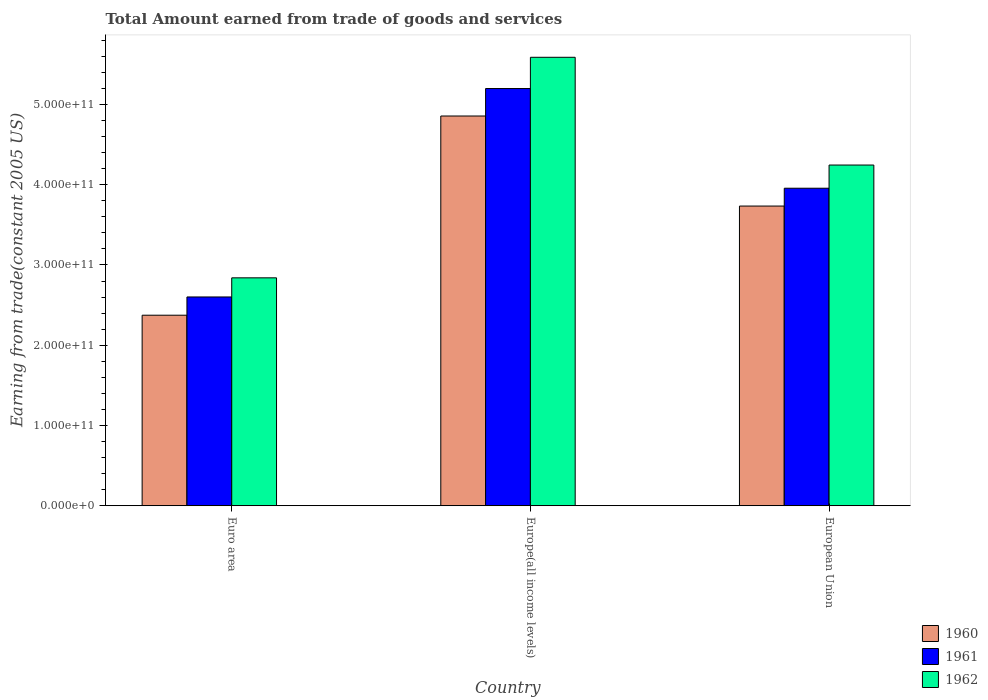How many different coloured bars are there?
Your answer should be compact. 3. How many bars are there on the 1st tick from the left?
Make the answer very short. 3. What is the label of the 1st group of bars from the left?
Keep it short and to the point. Euro area. In how many cases, is the number of bars for a given country not equal to the number of legend labels?
Give a very brief answer. 0. What is the total amount earned by trading goods and services in 1960 in Euro area?
Give a very brief answer. 2.37e+11. Across all countries, what is the maximum total amount earned by trading goods and services in 1961?
Ensure brevity in your answer.  5.20e+11. Across all countries, what is the minimum total amount earned by trading goods and services in 1962?
Offer a very short reply. 2.84e+11. In which country was the total amount earned by trading goods and services in 1960 maximum?
Make the answer very short. Europe(all income levels). What is the total total amount earned by trading goods and services in 1960 in the graph?
Keep it short and to the point. 1.10e+12. What is the difference between the total amount earned by trading goods and services in 1960 in Europe(all income levels) and that in European Union?
Make the answer very short. 1.12e+11. What is the difference between the total amount earned by trading goods and services in 1962 in Euro area and the total amount earned by trading goods and services in 1960 in Europe(all income levels)?
Your response must be concise. -2.02e+11. What is the average total amount earned by trading goods and services in 1961 per country?
Make the answer very short. 3.92e+11. What is the difference between the total amount earned by trading goods and services of/in 1960 and total amount earned by trading goods and services of/in 1962 in Europe(all income levels)?
Provide a succinct answer. -7.32e+1. In how many countries, is the total amount earned by trading goods and services in 1960 greater than 340000000000 US$?
Provide a short and direct response. 2. What is the ratio of the total amount earned by trading goods and services in 1961 in Euro area to that in Europe(all income levels)?
Provide a succinct answer. 0.5. What is the difference between the highest and the second highest total amount earned by trading goods and services in 1960?
Provide a short and direct response. 1.12e+11. What is the difference between the highest and the lowest total amount earned by trading goods and services in 1960?
Provide a short and direct response. 2.48e+11. How many bars are there?
Your answer should be very brief. 9. What is the difference between two consecutive major ticks on the Y-axis?
Provide a succinct answer. 1.00e+11. Are the values on the major ticks of Y-axis written in scientific E-notation?
Your answer should be compact. Yes. Does the graph contain any zero values?
Ensure brevity in your answer.  No. Where does the legend appear in the graph?
Your answer should be compact. Bottom right. How many legend labels are there?
Give a very brief answer. 3. What is the title of the graph?
Make the answer very short. Total Amount earned from trade of goods and services. What is the label or title of the Y-axis?
Offer a terse response. Earning from trade(constant 2005 US). What is the Earning from trade(constant 2005 US) in 1960 in Euro area?
Offer a terse response. 2.37e+11. What is the Earning from trade(constant 2005 US) of 1961 in Euro area?
Give a very brief answer. 2.60e+11. What is the Earning from trade(constant 2005 US) in 1962 in Euro area?
Your answer should be compact. 2.84e+11. What is the Earning from trade(constant 2005 US) in 1960 in Europe(all income levels)?
Offer a terse response. 4.86e+11. What is the Earning from trade(constant 2005 US) in 1961 in Europe(all income levels)?
Ensure brevity in your answer.  5.20e+11. What is the Earning from trade(constant 2005 US) of 1962 in Europe(all income levels)?
Offer a terse response. 5.59e+11. What is the Earning from trade(constant 2005 US) in 1960 in European Union?
Give a very brief answer. 3.73e+11. What is the Earning from trade(constant 2005 US) of 1961 in European Union?
Give a very brief answer. 3.96e+11. What is the Earning from trade(constant 2005 US) of 1962 in European Union?
Your answer should be very brief. 4.24e+11. Across all countries, what is the maximum Earning from trade(constant 2005 US) in 1960?
Provide a short and direct response. 4.86e+11. Across all countries, what is the maximum Earning from trade(constant 2005 US) of 1961?
Your answer should be compact. 5.20e+11. Across all countries, what is the maximum Earning from trade(constant 2005 US) in 1962?
Offer a very short reply. 5.59e+11. Across all countries, what is the minimum Earning from trade(constant 2005 US) in 1960?
Provide a succinct answer. 2.37e+11. Across all countries, what is the minimum Earning from trade(constant 2005 US) of 1961?
Your answer should be compact. 2.60e+11. Across all countries, what is the minimum Earning from trade(constant 2005 US) in 1962?
Make the answer very short. 2.84e+11. What is the total Earning from trade(constant 2005 US) in 1960 in the graph?
Provide a succinct answer. 1.10e+12. What is the total Earning from trade(constant 2005 US) in 1961 in the graph?
Offer a very short reply. 1.18e+12. What is the total Earning from trade(constant 2005 US) of 1962 in the graph?
Your answer should be compact. 1.27e+12. What is the difference between the Earning from trade(constant 2005 US) of 1960 in Euro area and that in Europe(all income levels)?
Your answer should be very brief. -2.48e+11. What is the difference between the Earning from trade(constant 2005 US) of 1961 in Euro area and that in Europe(all income levels)?
Offer a very short reply. -2.60e+11. What is the difference between the Earning from trade(constant 2005 US) of 1962 in Euro area and that in Europe(all income levels)?
Offer a very short reply. -2.75e+11. What is the difference between the Earning from trade(constant 2005 US) of 1960 in Euro area and that in European Union?
Keep it short and to the point. -1.36e+11. What is the difference between the Earning from trade(constant 2005 US) in 1961 in Euro area and that in European Union?
Your answer should be compact. -1.35e+11. What is the difference between the Earning from trade(constant 2005 US) in 1962 in Euro area and that in European Union?
Ensure brevity in your answer.  -1.41e+11. What is the difference between the Earning from trade(constant 2005 US) of 1960 in Europe(all income levels) and that in European Union?
Offer a terse response. 1.12e+11. What is the difference between the Earning from trade(constant 2005 US) in 1961 in Europe(all income levels) and that in European Union?
Ensure brevity in your answer.  1.24e+11. What is the difference between the Earning from trade(constant 2005 US) of 1962 in Europe(all income levels) and that in European Union?
Offer a very short reply. 1.34e+11. What is the difference between the Earning from trade(constant 2005 US) in 1960 in Euro area and the Earning from trade(constant 2005 US) in 1961 in Europe(all income levels)?
Provide a short and direct response. -2.82e+11. What is the difference between the Earning from trade(constant 2005 US) of 1960 in Euro area and the Earning from trade(constant 2005 US) of 1962 in Europe(all income levels)?
Your answer should be compact. -3.21e+11. What is the difference between the Earning from trade(constant 2005 US) of 1961 in Euro area and the Earning from trade(constant 2005 US) of 1962 in Europe(all income levels)?
Your answer should be very brief. -2.99e+11. What is the difference between the Earning from trade(constant 2005 US) of 1960 in Euro area and the Earning from trade(constant 2005 US) of 1961 in European Union?
Ensure brevity in your answer.  -1.58e+11. What is the difference between the Earning from trade(constant 2005 US) of 1960 in Euro area and the Earning from trade(constant 2005 US) of 1962 in European Union?
Give a very brief answer. -1.87e+11. What is the difference between the Earning from trade(constant 2005 US) of 1961 in Euro area and the Earning from trade(constant 2005 US) of 1962 in European Union?
Your response must be concise. -1.64e+11. What is the difference between the Earning from trade(constant 2005 US) in 1960 in Europe(all income levels) and the Earning from trade(constant 2005 US) in 1961 in European Union?
Offer a very short reply. 9.00e+1. What is the difference between the Earning from trade(constant 2005 US) in 1960 in Europe(all income levels) and the Earning from trade(constant 2005 US) in 1962 in European Union?
Make the answer very short. 6.11e+1. What is the difference between the Earning from trade(constant 2005 US) of 1961 in Europe(all income levels) and the Earning from trade(constant 2005 US) of 1962 in European Union?
Give a very brief answer. 9.53e+1. What is the average Earning from trade(constant 2005 US) in 1960 per country?
Provide a short and direct response. 3.65e+11. What is the average Earning from trade(constant 2005 US) in 1961 per country?
Your answer should be compact. 3.92e+11. What is the average Earning from trade(constant 2005 US) in 1962 per country?
Keep it short and to the point. 4.22e+11. What is the difference between the Earning from trade(constant 2005 US) in 1960 and Earning from trade(constant 2005 US) in 1961 in Euro area?
Provide a short and direct response. -2.27e+1. What is the difference between the Earning from trade(constant 2005 US) of 1960 and Earning from trade(constant 2005 US) of 1962 in Euro area?
Provide a short and direct response. -4.66e+1. What is the difference between the Earning from trade(constant 2005 US) in 1961 and Earning from trade(constant 2005 US) in 1962 in Euro area?
Offer a terse response. -2.38e+1. What is the difference between the Earning from trade(constant 2005 US) in 1960 and Earning from trade(constant 2005 US) in 1961 in Europe(all income levels)?
Give a very brief answer. -3.42e+1. What is the difference between the Earning from trade(constant 2005 US) in 1960 and Earning from trade(constant 2005 US) in 1962 in Europe(all income levels)?
Offer a terse response. -7.32e+1. What is the difference between the Earning from trade(constant 2005 US) in 1961 and Earning from trade(constant 2005 US) in 1962 in Europe(all income levels)?
Provide a short and direct response. -3.89e+1. What is the difference between the Earning from trade(constant 2005 US) in 1960 and Earning from trade(constant 2005 US) in 1961 in European Union?
Offer a very short reply. -2.22e+1. What is the difference between the Earning from trade(constant 2005 US) of 1960 and Earning from trade(constant 2005 US) of 1962 in European Union?
Offer a terse response. -5.11e+1. What is the difference between the Earning from trade(constant 2005 US) in 1961 and Earning from trade(constant 2005 US) in 1962 in European Union?
Keep it short and to the point. -2.89e+1. What is the ratio of the Earning from trade(constant 2005 US) of 1960 in Euro area to that in Europe(all income levels)?
Offer a terse response. 0.49. What is the ratio of the Earning from trade(constant 2005 US) of 1961 in Euro area to that in Europe(all income levels)?
Offer a very short reply. 0.5. What is the ratio of the Earning from trade(constant 2005 US) of 1962 in Euro area to that in Europe(all income levels)?
Keep it short and to the point. 0.51. What is the ratio of the Earning from trade(constant 2005 US) of 1960 in Euro area to that in European Union?
Your answer should be compact. 0.64. What is the ratio of the Earning from trade(constant 2005 US) in 1961 in Euro area to that in European Union?
Your response must be concise. 0.66. What is the ratio of the Earning from trade(constant 2005 US) of 1962 in Euro area to that in European Union?
Give a very brief answer. 0.67. What is the ratio of the Earning from trade(constant 2005 US) in 1960 in Europe(all income levels) to that in European Union?
Keep it short and to the point. 1.3. What is the ratio of the Earning from trade(constant 2005 US) of 1961 in Europe(all income levels) to that in European Union?
Your response must be concise. 1.31. What is the ratio of the Earning from trade(constant 2005 US) of 1962 in Europe(all income levels) to that in European Union?
Provide a succinct answer. 1.32. What is the difference between the highest and the second highest Earning from trade(constant 2005 US) in 1960?
Ensure brevity in your answer.  1.12e+11. What is the difference between the highest and the second highest Earning from trade(constant 2005 US) of 1961?
Your response must be concise. 1.24e+11. What is the difference between the highest and the second highest Earning from trade(constant 2005 US) in 1962?
Ensure brevity in your answer.  1.34e+11. What is the difference between the highest and the lowest Earning from trade(constant 2005 US) in 1960?
Your answer should be compact. 2.48e+11. What is the difference between the highest and the lowest Earning from trade(constant 2005 US) in 1961?
Make the answer very short. 2.60e+11. What is the difference between the highest and the lowest Earning from trade(constant 2005 US) in 1962?
Your answer should be very brief. 2.75e+11. 